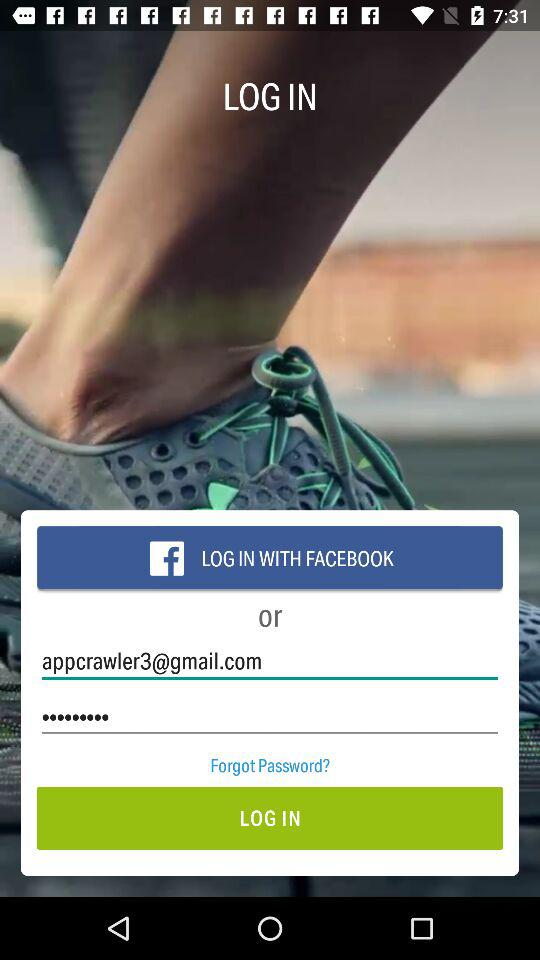What is the given email address? The given email address is appcrawler3@gmail.com. 